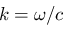<formula> <loc_0><loc_0><loc_500><loc_500>k = \omega / c</formula> 